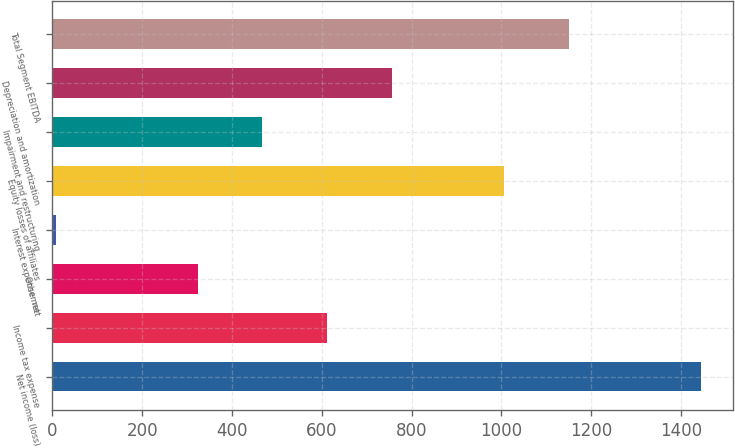<chart> <loc_0><loc_0><loc_500><loc_500><bar_chart><fcel>Net income (loss)<fcel>Income tax expense<fcel>Other net<fcel>Interest expense net<fcel>Equity losses of affiliates<fcel>Impairment and restructuring<fcel>Depreciation and amortization<fcel>Total Segment EBITDA<nl><fcel>1444<fcel>611.4<fcel>324<fcel>7<fcel>1006<fcel>467.7<fcel>755.1<fcel>1149.7<nl></chart> 